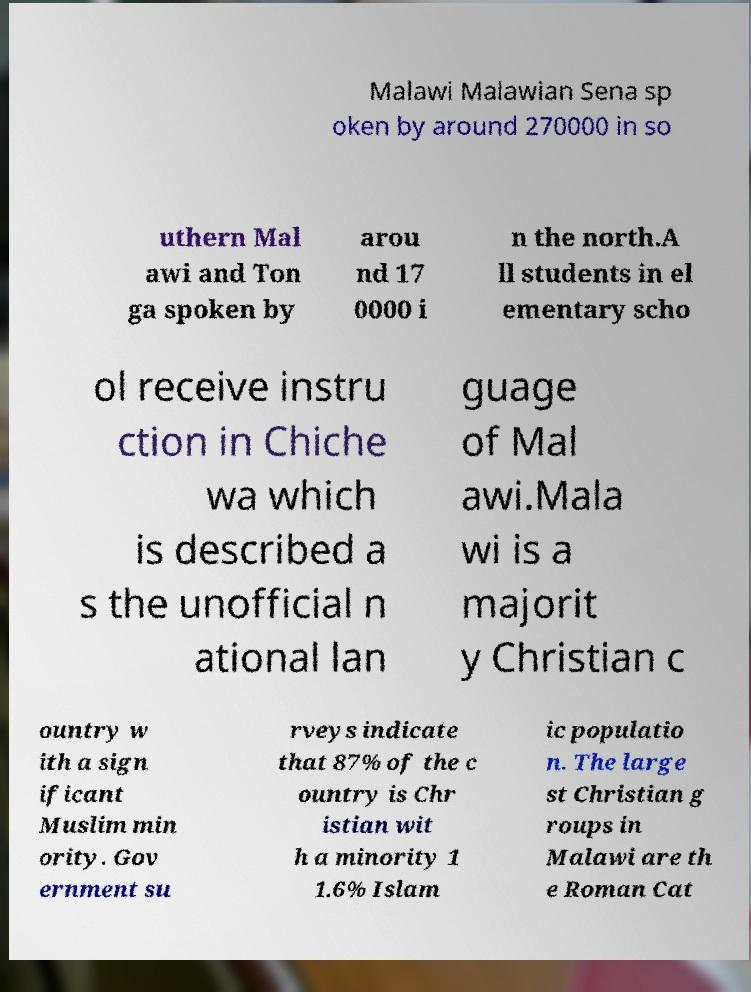Can you read and provide the text displayed in the image?This photo seems to have some interesting text. Can you extract and type it out for me? Malawi Malawian Sena sp oken by around 270000 in so uthern Mal awi and Ton ga spoken by arou nd 17 0000 i n the north.A ll students in el ementary scho ol receive instru ction in Chiche wa which is described a s the unofficial n ational lan guage of Mal awi.Mala wi is a majorit y Christian c ountry w ith a sign ificant Muslim min ority. Gov ernment su rveys indicate that 87% of the c ountry is Chr istian wit h a minority 1 1.6% Islam ic populatio n. The large st Christian g roups in Malawi are th e Roman Cat 